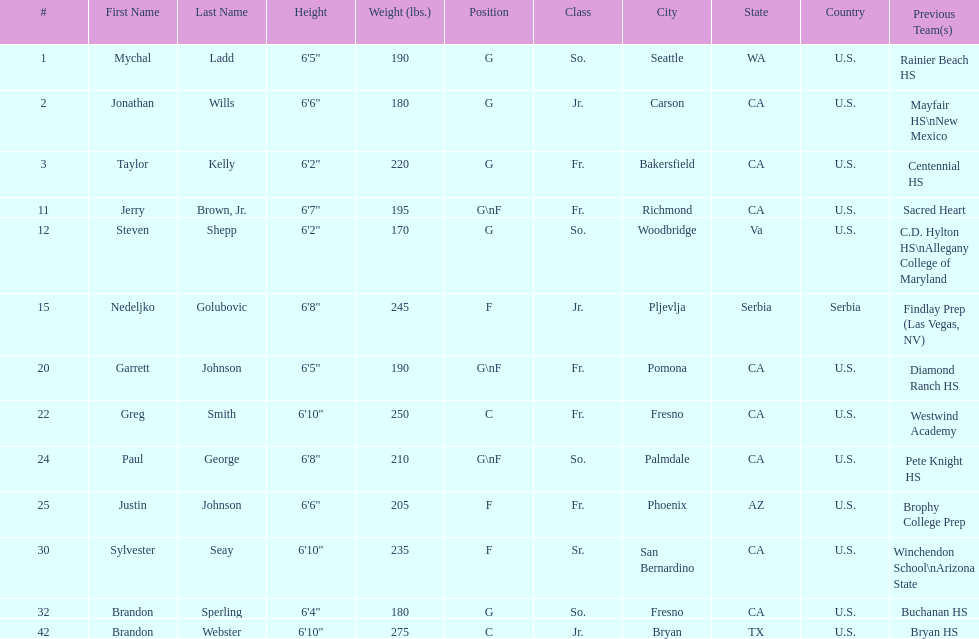Which player who is only a forward (f) is the shortest? Justin Johnson. 